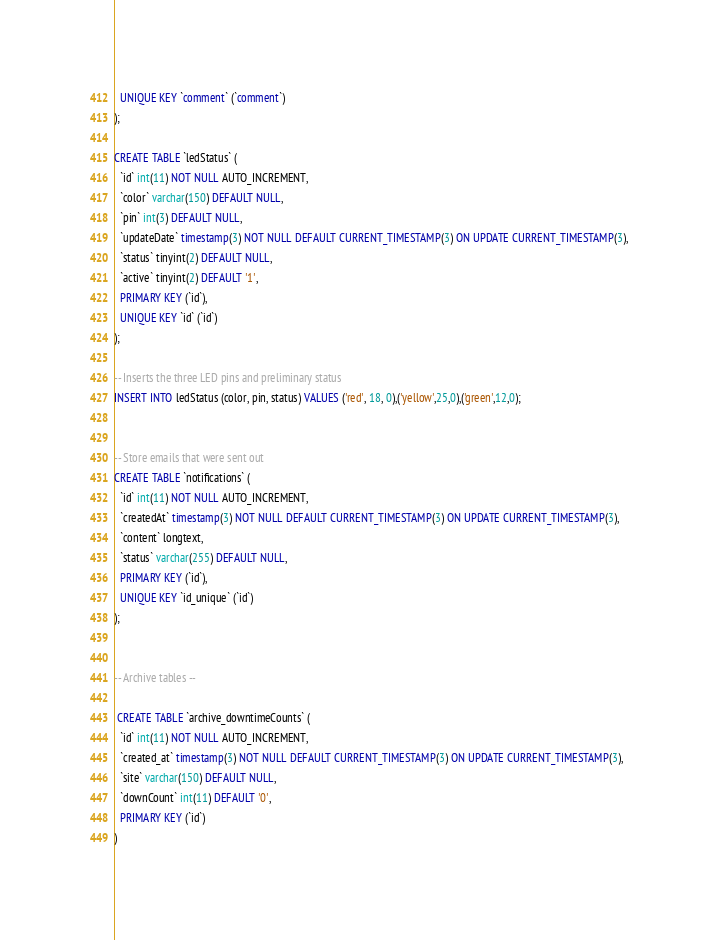Convert code to text. <code><loc_0><loc_0><loc_500><loc_500><_SQL_>  UNIQUE KEY `comment` (`comment`)
);

CREATE TABLE `ledStatus` (
  `id` int(11) NOT NULL AUTO_INCREMENT,
  `color` varchar(150) DEFAULT NULL,
  `pin` int(3) DEFAULT NULL,
  `updateDate` timestamp(3) NOT NULL DEFAULT CURRENT_TIMESTAMP(3) ON UPDATE CURRENT_TIMESTAMP(3),
  `status` tinyint(2) DEFAULT NULL,
  `active` tinyint(2) DEFAULT '1',
  PRIMARY KEY (`id`),
  UNIQUE KEY `id` (`id`)
);

-- Inserts the three LED pins and preliminary status
INSERT INTO ledStatus (color, pin, status) VALUES ('red', 18, 0),('yellow',25,0),('green',12,0);


-- Store emails that were sent out
CREATE TABLE `notifications` (
  `id` int(11) NOT NULL AUTO_INCREMENT,
  `createdAt` timestamp(3) NOT NULL DEFAULT CURRENT_TIMESTAMP(3) ON UPDATE CURRENT_TIMESTAMP(3),
  `content` longtext,
  `status` varchar(255) DEFAULT NULL,
  PRIMARY KEY (`id`),
  UNIQUE KEY `id_unique` (`id`)
);


-- Archive tables --

 CREATE TABLE `archive_downtimeCounts` (
  `id` int(11) NOT NULL AUTO_INCREMENT,
  `created_at` timestamp(3) NOT NULL DEFAULT CURRENT_TIMESTAMP(3) ON UPDATE CURRENT_TIMESTAMP(3),
  `site` varchar(150) DEFAULT NULL,
  `downCount` int(11) DEFAULT '0',
  PRIMARY KEY (`id`)
)</code> 